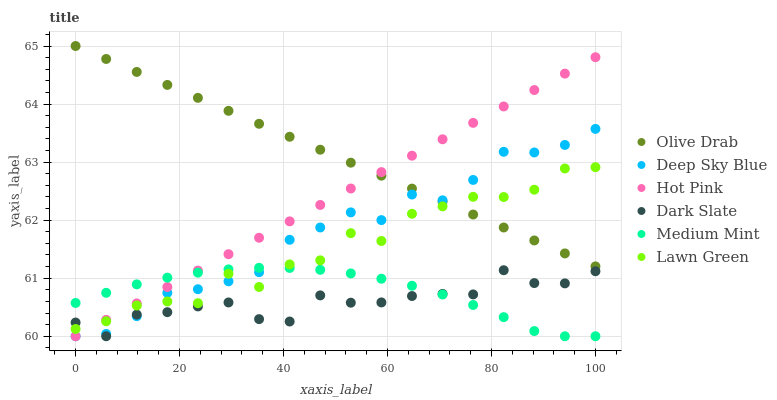Does Dark Slate have the minimum area under the curve?
Answer yes or no. Yes. Does Olive Drab have the maximum area under the curve?
Answer yes or no. Yes. Does Lawn Green have the minimum area under the curve?
Answer yes or no. No. Does Lawn Green have the maximum area under the curve?
Answer yes or no. No. Is Hot Pink the smoothest?
Answer yes or no. Yes. Is Lawn Green the roughest?
Answer yes or no. Yes. Is Lawn Green the smoothest?
Answer yes or no. No. Is Hot Pink the roughest?
Answer yes or no. No. Does Medium Mint have the lowest value?
Answer yes or no. Yes. Does Lawn Green have the lowest value?
Answer yes or no. No. Does Olive Drab have the highest value?
Answer yes or no. Yes. Does Lawn Green have the highest value?
Answer yes or no. No. Is Dark Slate less than Olive Drab?
Answer yes or no. Yes. Is Olive Drab greater than Dark Slate?
Answer yes or no. Yes. Does Hot Pink intersect Olive Drab?
Answer yes or no. Yes. Is Hot Pink less than Olive Drab?
Answer yes or no. No. Is Hot Pink greater than Olive Drab?
Answer yes or no. No. Does Dark Slate intersect Olive Drab?
Answer yes or no. No. 